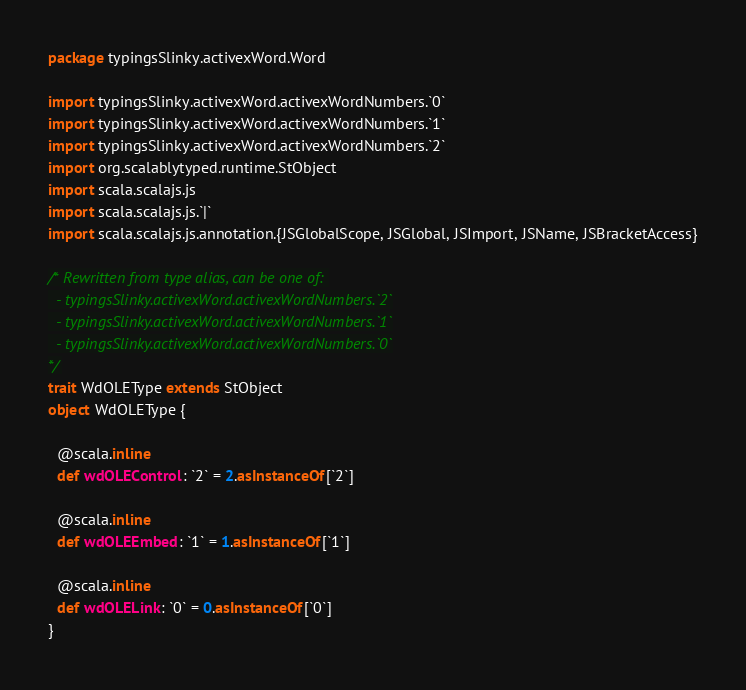<code> <loc_0><loc_0><loc_500><loc_500><_Scala_>package typingsSlinky.activexWord.Word

import typingsSlinky.activexWord.activexWordNumbers.`0`
import typingsSlinky.activexWord.activexWordNumbers.`1`
import typingsSlinky.activexWord.activexWordNumbers.`2`
import org.scalablytyped.runtime.StObject
import scala.scalajs.js
import scala.scalajs.js.`|`
import scala.scalajs.js.annotation.{JSGlobalScope, JSGlobal, JSImport, JSName, JSBracketAccess}

/* Rewritten from type alias, can be one of: 
  - typingsSlinky.activexWord.activexWordNumbers.`2`
  - typingsSlinky.activexWord.activexWordNumbers.`1`
  - typingsSlinky.activexWord.activexWordNumbers.`0`
*/
trait WdOLEType extends StObject
object WdOLEType {
  
  @scala.inline
  def wdOLEControl: `2` = 2.asInstanceOf[`2`]
  
  @scala.inline
  def wdOLEEmbed: `1` = 1.asInstanceOf[`1`]
  
  @scala.inline
  def wdOLELink: `0` = 0.asInstanceOf[`0`]
}
</code> 